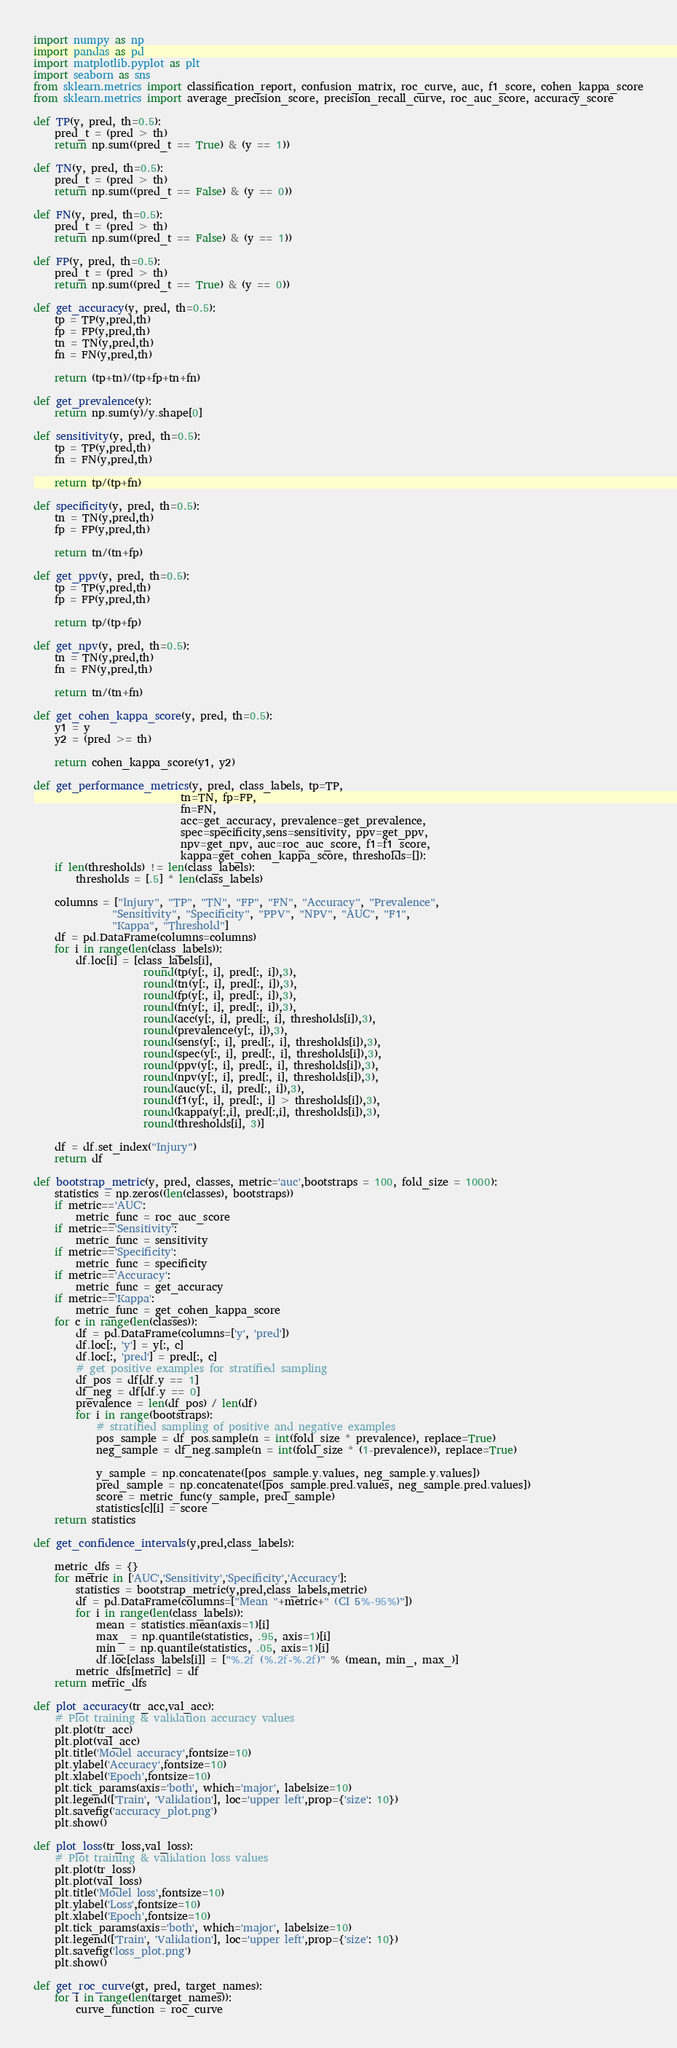Convert code to text. <code><loc_0><loc_0><loc_500><loc_500><_Python_>import numpy as np
import pandas as pd
import matplotlib.pyplot as plt
import seaborn as sns
from sklearn.metrics import classification_report, confusion_matrix, roc_curve, auc, f1_score, cohen_kappa_score
from sklearn.metrics import average_precision_score, precision_recall_curve, roc_auc_score, accuracy_score

def TP(y, pred, th=0.5):
    pred_t = (pred > th)
    return np.sum((pred_t == True) & (y == 1))

def TN(y, pred, th=0.5):
    pred_t = (pred > th)
    return np.sum((pred_t == False) & (y == 0))

def FN(y, pred, th=0.5):
    pred_t = (pred > th)
    return np.sum((pred_t == False) & (y == 1))

def FP(y, pred, th=0.5):
    pred_t = (pred > th)
    return np.sum((pred_t == True) & (y == 0))

def get_accuracy(y, pred, th=0.5):
    tp = TP(y,pred,th)
    fp = FP(y,pred,th)
    tn = TN(y,pred,th)
    fn = FN(y,pred,th)

    return (tp+tn)/(tp+fp+tn+fn)

def get_prevalence(y):
    return np.sum(y)/y.shape[0]

def sensitivity(y, pred, th=0.5):
    tp = TP(y,pred,th)
    fn = FN(y,pred,th)

    return tp/(tp+fn)

def specificity(y, pred, th=0.5):
    tn = TN(y,pred,th)
    fp = FP(y,pred,th)

    return tn/(tn+fp)

def get_ppv(y, pred, th=0.5):
    tp = TP(y,pred,th)
    fp = FP(y,pred,th)

    return tp/(tp+fp)

def get_npv(y, pred, th=0.5):
    tn = TN(y,pred,th)
    fn = FN(y,pred,th)

    return tn/(tn+fn)

def get_cohen_kappa_score(y, pred, th=0.5):
    y1 = y
    y2 = (pred >= th)

    return cohen_kappa_score(y1, y2)

def get_performance_metrics(y, pred, class_labels, tp=TP,
                            tn=TN, fp=FP,
                            fn=FN,
                            acc=get_accuracy, prevalence=get_prevalence,
                            spec=specificity,sens=sensitivity, ppv=get_ppv,
                            npv=get_npv, auc=roc_auc_score, f1=f1_score, 
                            kappa=get_cohen_kappa_score, thresholds=[]):
    if len(thresholds) != len(class_labels):
        thresholds = [.5] * len(class_labels)

    columns = ["Injury", "TP", "TN", "FP", "FN", "Accuracy", "Prevalence",
               "Sensitivity", "Specificity", "PPV", "NPV", "AUC", "F1", 
               "Kappa", "Threshold"]
    df = pd.DataFrame(columns=columns)
    for i in range(len(class_labels)):
        df.loc[i] = [class_labels[i],
                     round(tp(y[:, i], pred[:, i]),3),
                     round(tn(y[:, i], pred[:, i]),3),
                     round(fp(y[:, i], pred[:, i]),3),
                     round(fn(y[:, i], pred[:, i]),3),
                     round(acc(y[:, i], pred[:, i], thresholds[i]),3),
                     round(prevalence(y[:, i]),3),
                     round(sens(y[:, i], pred[:, i], thresholds[i]),3),
                     round(spec(y[:, i], pred[:, i], thresholds[i]),3),
                     round(ppv(y[:, i], pred[:, i], thresholds[i]),3),
                     round(npv(y[:, i], pred[:, i], thresholds[i]),3),
                     round(auc(y[:, i], pred[:, i]),3),
                     round(f1(y[:, i], pred[:, i] > thresholds[i]),3),
                     round(kappa(y[:,i], pred[:,i], thresholds[i]),3),
                     round(thresholds[i], 3)]

    df = df.set_index("Injury")
    return df

def bootstrap_metric(y, pred, classes, metric='auc',bootstraps = 100, fold_size = 1000):
    statistics = np.zeros((len(classes), bootstraps))
    if metric=='AUC':
        metric_func = roc_auc_score
    if metric=='Sensitivity':
        metric_func = sensitivity
    if metric=='Specificity':
        metric_func = specificity
    if metric=='Accuracy':
        metric_func = get_accuracy
    if metric=='Kappa':
        metric_func = get_cohen_kappa_score
    for c in range(len(classes)):
        df = pd.DataFrame(columns=['y', 'pred'])
        df.loc[:, 'y'] = y[:, c]
        df.loc[:, 'pred'] = pred[:, c]
        # get positive examples for stratified sampling
        df_pos = df[df.y == 1]
        df_neg = df[df.y == 0]
        prevalence = len(df_pos) / len(df)
        for i in range(bootstraps):
            # stratified sampling of positive and negative examples
            pos_sample = df_pos.sample(n = int(fold_size * prevalence), replace=True)
            neg_sample = df_neg.sample(n = int(fold_size * (1-prevalence)), replace=True)

            y_sample = np.concatenate([pos_sample.y.values, neg_sample.y.values])
            pred_sample = np.concatenate([pos_sample.pred.values, neg_sample.pred.values])
            score = metric_func(y_sample, pred_sample)
            statistics[c][i] = score
    return statistics

def get_confidence_intervals(y,pred,class_labels):

    metric_dfs = {}
    for metric in ['AUC','Sensitivity','Specificity','Accuracy']:
        statistics = bootstrap_metric(y,pred,class_labels,metric)
        df = pd.DataFrame(columns=["Mean "+metric+" (CI 5%-95%)"])
        for i in range(len(class_labels)):
            mean = statistics.mean(axis=1)[i]
            max_ = np.quantile(statistics, .95, axis=1)[i]
            min_ = np.quantile(statistics, .05, axis=1)[i]
            df.loc[class_labels[i]] = ["%.2f (%.2f-%.2f)" % (mean, min_, max_)]
        metric_dfs[metric] = df
    return metric_dfs

def plot_accuracy(tr_acc,val_acc):
    # Plot training & validation accuracy values
    plt.plot(tr_acc)
    plt.plot(val_acc)
    plt.title('Model accuracy',fontsize=10)
    plt.ylabel('Accuracy',fontsize=10)
    plt.xlabel('Epoch',fontsize=10)
    plt.tick_params(axis='both', which='major', labelsize=10)
    plt.legend(['Train', 'Validation'], loc='upper left',prop={'size': 10})
    plt.savefig('accuracy_plot.png')
    plt.show()

def plot_loss(tr_loss,val_loss):
    # Plot training & validation loss values
    plt.plot(tr_loss)
    plt.plot(val_loss)
    plt.title('Model loss',fontsize=10)
    plt.ylabel('Loss',fontsize=10)
    plt.xlabel('Epoch',fontsize=10)
    plt.tick_params(axis='both', which='major', labelsize=10)
    plt.legend(['Train', 'Validation'], loc='upper left',prop={'size': 10})
    plt.savefig('loss_plot.png')
    plt.show()

def get_roc_curve(gt, pred, target_names):
    for i in range(len(target_names)):
        curve_function = roc_curve</code> 